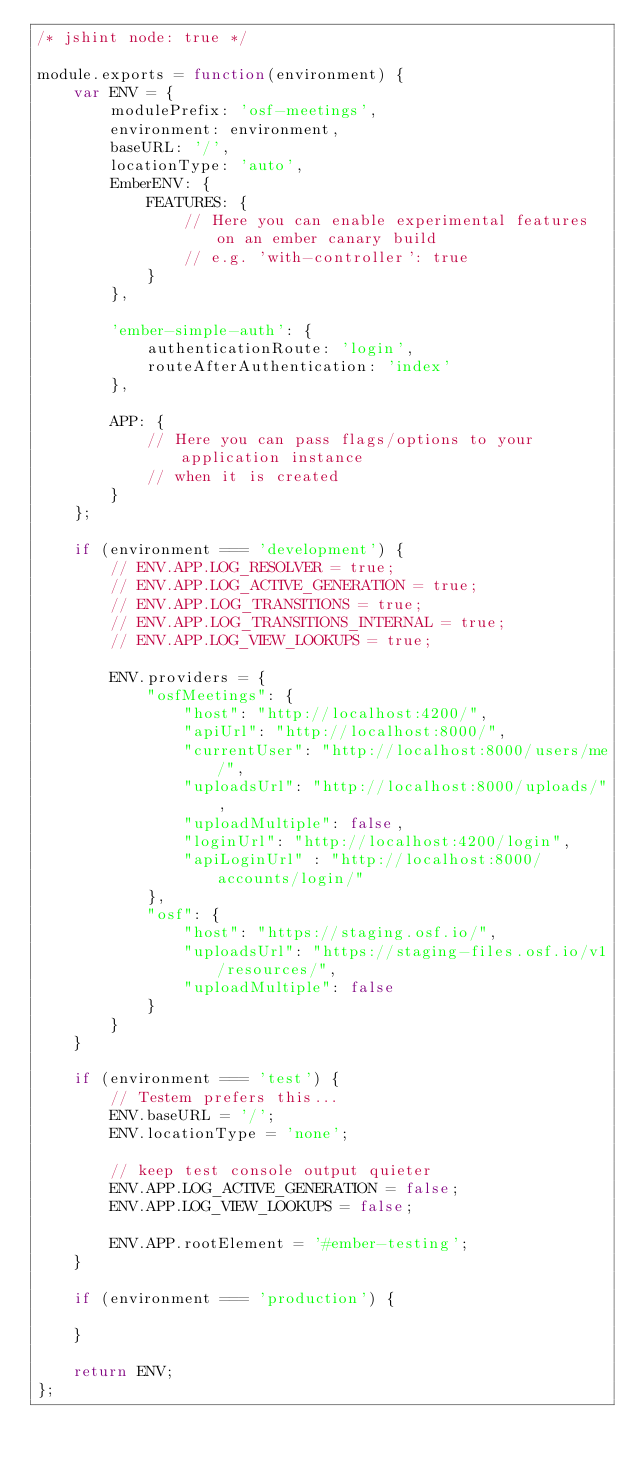<code> <loc_0><loc_0><loc_500><loc_500><_JavaScript_>/* jshint node: true */

module.exports = function(environment) {
    var ENV = {
        modulePrefix: 'osf-meetings',
        environment: environment,
        baseURL: '/',
        locationType: 'auto',
        EmberENV: {
            FEATURES: {
                // Here you can enable experimental features on an ember canary build
                // e.g. 'with-controller': true
            }
        },

        'ember-simple-auth': {
            authenticationRoute: 'login',
            routeAfterAuthentication: 'index'
        },

        APP: {
            // Here you can pass flags/options to your application instance
            // when it is created
        }
    };

    if (environment === 'development') {
        // ENV.APP.LOG_RESOLVER = true;
        // ENV.APP.LOG_ACTIVE_GENERATION = true;
        // ENV.APP.LOG_TRANSITIONS = true;
        // ENV.APP.LOG_TRANSITIONS_INTERNAL = true;
        // ENV.APP.LOG_VIEW_LOOKUPS = true;

        ENV.providers = {
            "osfMeetings": {
                "host": "http://localhost:4200/",
                "apiUrl": "http://localhost:8000/",
                "currentUser": "http://localhost:8000/users/me/",
                "uploadsUrl": "http://localhost:8000/uploads/",
                "uploadMultiple": false,
                "loginUrl": "http://localhost:4200/login",
                "apiLoginUrl" : "http://localhost:8000/accounts/login/"
            },
            "osf": {
                "host": "https://staging.osf.io/",
                "uploadsUrl": "https://staging-files.osf.io/v1/resources/",
                "uploadMultiple": false
            }
        }
    }

    if (environment === 'test') {
        // Testem prefers this...
        ENV.baseURL = '/';
        ENV.locationType = 'none';

        // keep test console output quieter
        ENV.APP.LOG_ACTIVE_GENERATION = false;
        ENV.APP.LOG_VIEW_LOOKUPS = false;

        ENV.APP.rootElement = '#ember-testing';
    }

    if (environment === 'production') {

    }

    return ENV;
};
</code> 